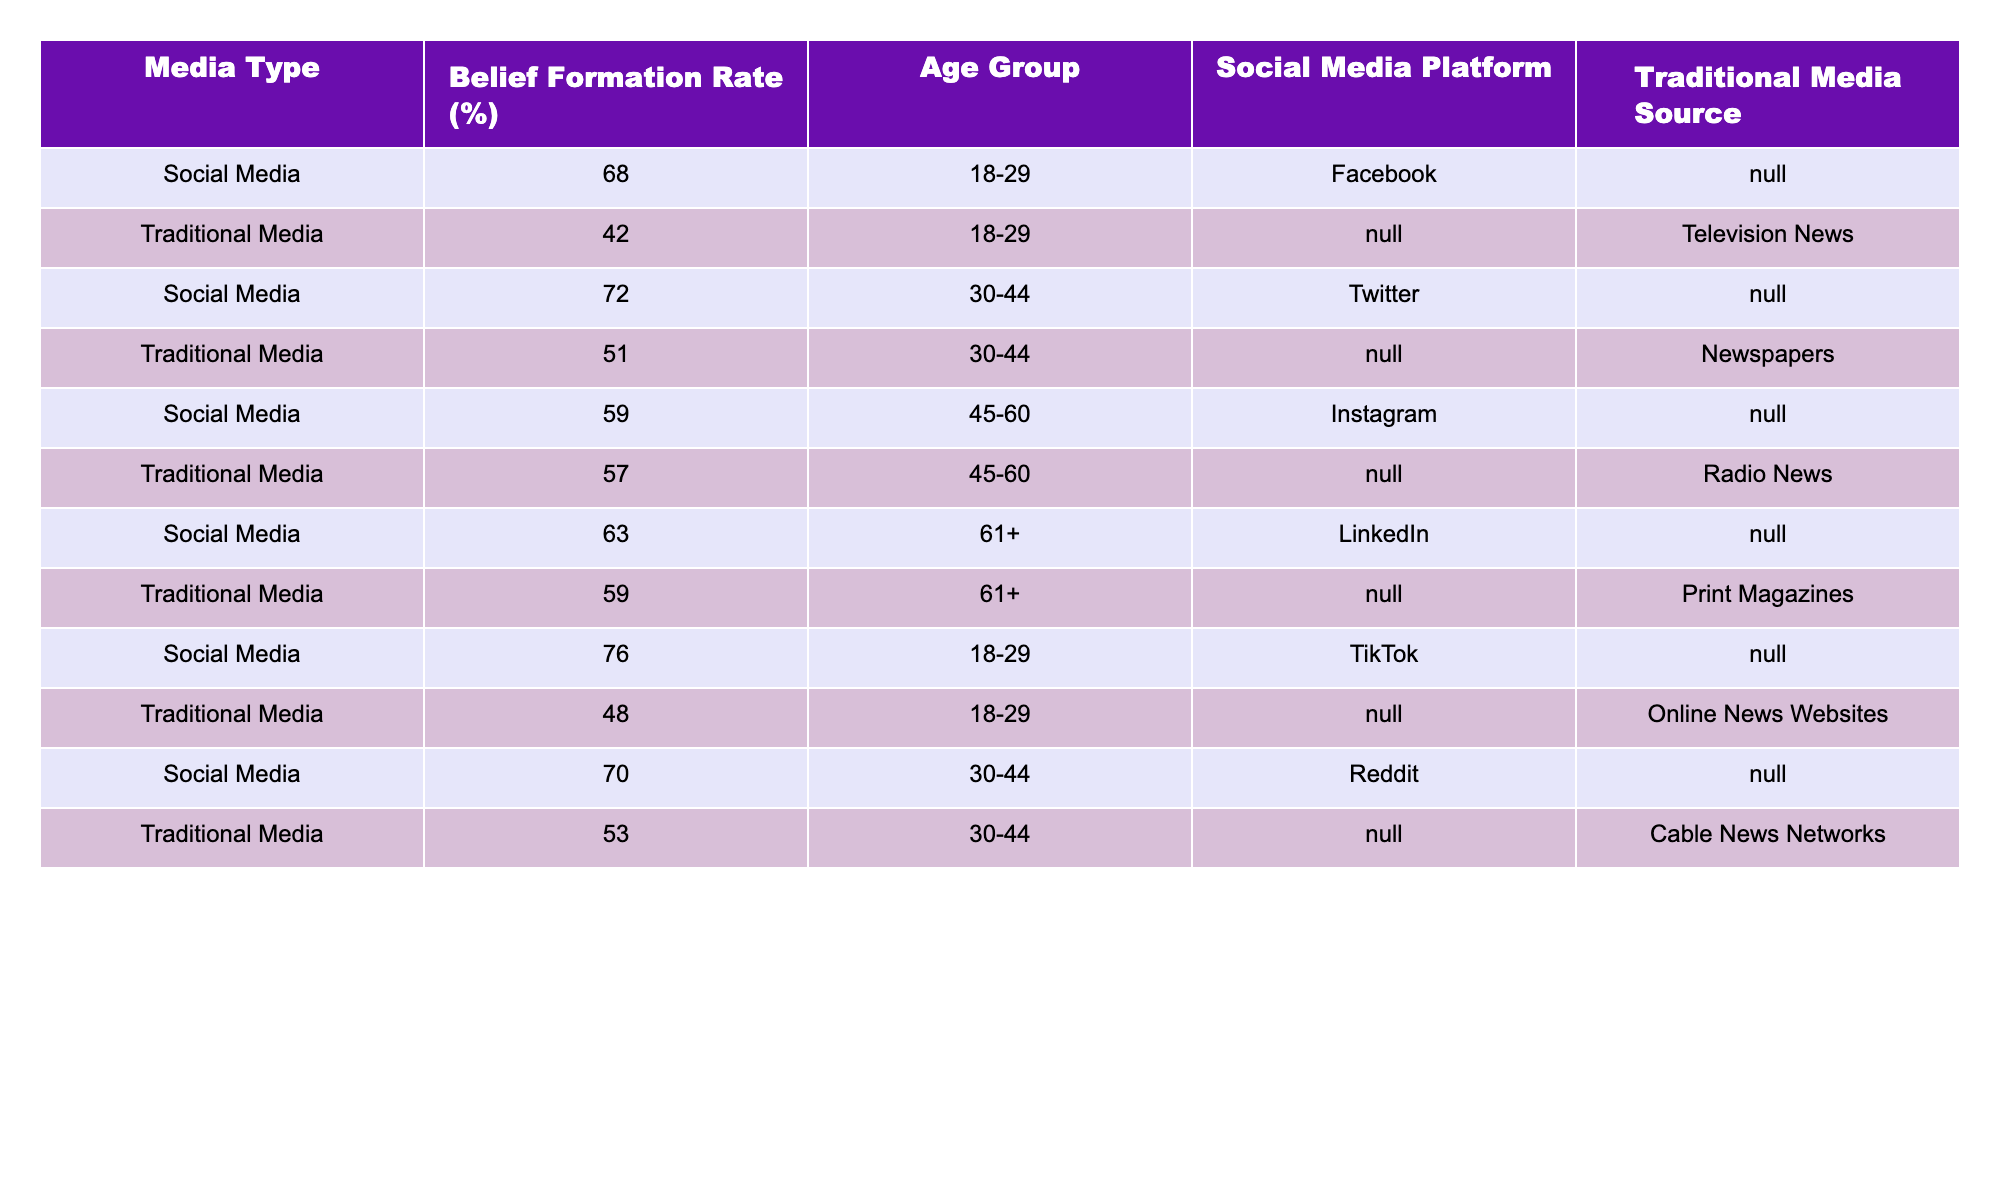What is the belief formation rate for the 45-60 age group on social media? From the table, the belief formation rates for the 45-60 age group using social media are 59 percent for Instagram.
Answer: 59% What is the belief formation rate for traditional media in the 18-29 age group? The table indicates that the belief formation rate for traditional media in the 18-29 age group is 42 percent, based on the data from Television News.
Answer: 42% Which social media platform has the highest belief formation rate in the 18-29 age group? According to the table, TikTok has the highest belief formation rate in the 18-29 age group with a rate of 76 percent.
Answer: 76% What is the average belief formation rate for traditional media sources across all age groups? To calculate the average for traditional media, we sum the rates: 42 + 51 + 57 + 59 + 48 + 53 = 310. There are 6 data points, so the average is 310 / 6 = approximately 51.67 percent.
Answer: 51.67% Is it true that the belief formation rate for social media is higher than that for traditional media in the 30-44 age group? Yes, the belief formation rate for social media in the 30-44 age group is 72 percent (Twitter) while for traditional media it is 51 percent (Newspapers).
Answer: Yes In which age group and media type is the smallest difference in belief formation rates observed? By looking at the differences between the rates, the smallest difference occurs in the 45-60 age group with social media at 59 percent (Instagram) and traditional media at 57 percent (Radio News), giving a difference of 2 percent.
Answer: 2 percent in the 45-60 age group What is the total belief formation rate difference for age groups 18-29 and 30-44 when comparing social media to traditional media? For 18-29, the difference is 76 - 42 = 34 percent; for 30-44, it's 72 - 51 = 21 percent. Therefore, the total difference is 34 + 21 = 55 percent.
Answer: 55 percent What is the belief formation rate for the 61+ age group using traditional media? The table shows that the belief formation rate for the 61+ age group using traditional media is 59 percent, sourced from Print Magazines.
Answer: 59% Is the belief formation rate for social media consistently higher than for traditional media across all age groups? Yes, in all age groups analyzed, the belief formation rate for social media surpasses that of traditional media, indicating a consistent trend.
Answer: Yes 